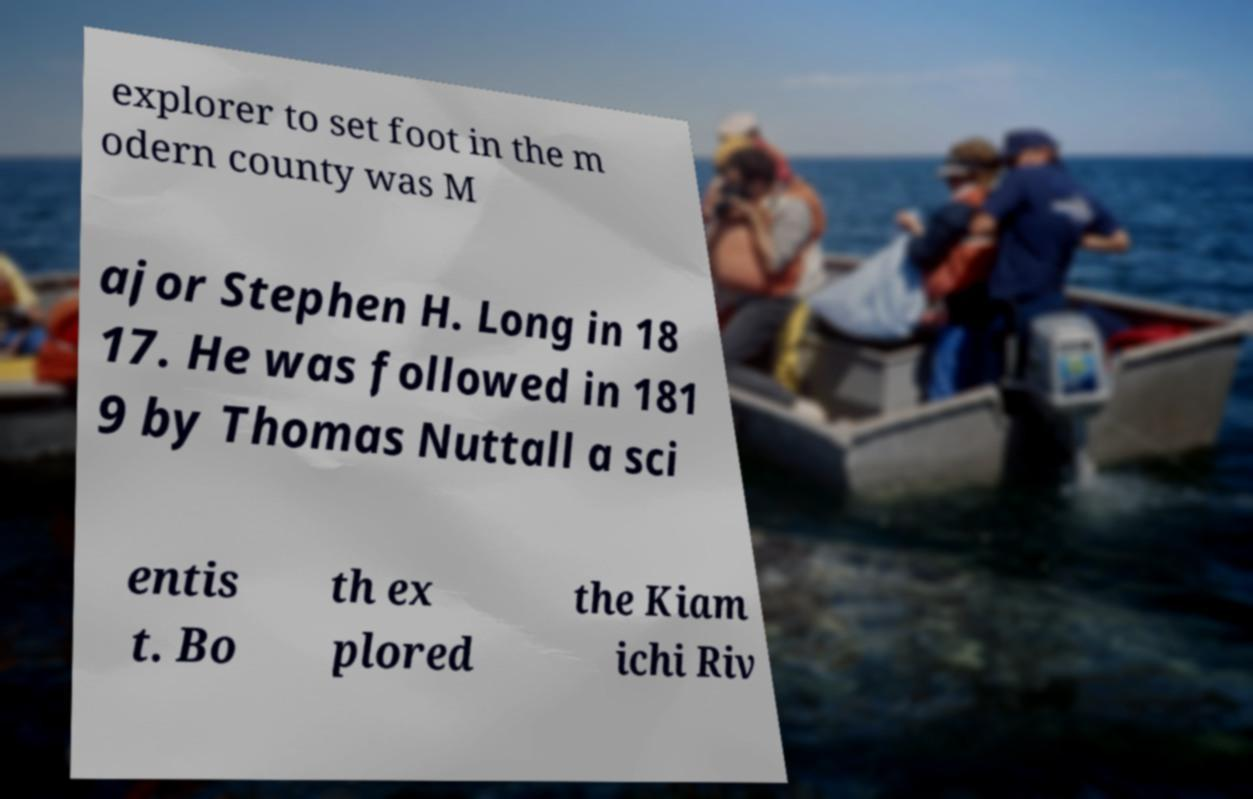Can you read and provide the text displayed in the image?This photo seems to have some interesting text. Can you extract and type it out for me? explorer to set foot in the m odern county was M ajor Stephen H. Long in 18 17. He was followed in 181 9 by Thomas Nuttall a sci entis t. Bo th ex plored the Kiam ichi Riv 